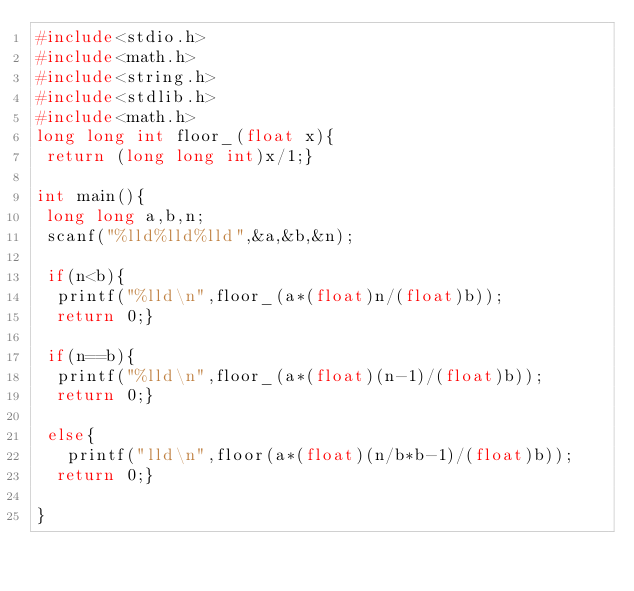Convert code to text. <code><loc_0><loc_0><loc_500><loc_500><_C_>#include<stdio.h>
#include<math.h>
#include<string.h>
#include<stdlib.h>
#include<math.h>
long long int floor_(float x){
 return (long long int)x/1;}

int main(){
 long long a,b,n;
 scanf("%lld%lld%lld",&a,&b,&n);
 
 if(n<b){
  printf("%lld\n",floor_(a*(float)n/(float)b));
  return 0;}
 
 if(n==b){
  printf("%lld\n",floor_(a*(float)(n-1)/(float)b));
  return 0;}
  
 else{
   printf("lld\n",floor(a*(float)(n/b*b-1)/(float)b));
  return 0;}

} </code> 